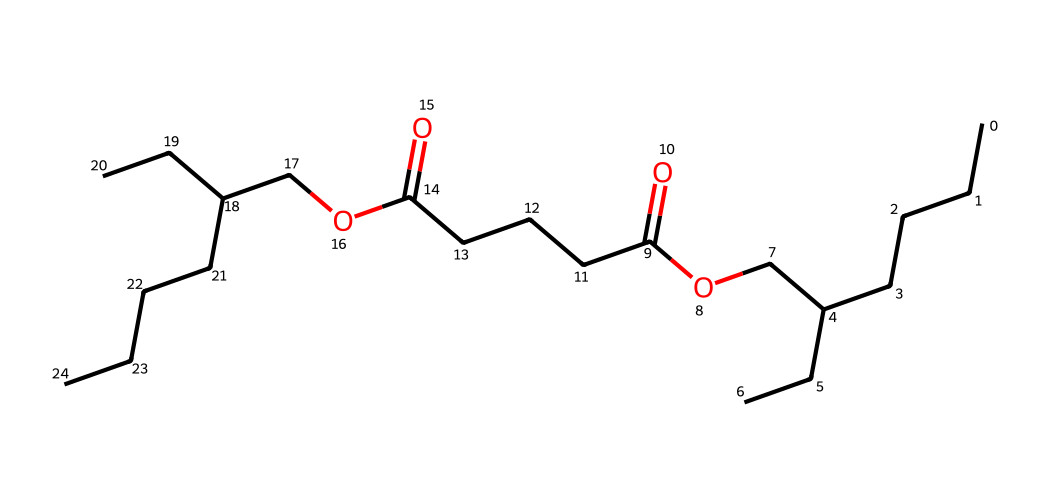how many carbon atoms are in the chemical? By analyzing the SMILES representation, we can count the number of 'C' characters, which represent carbon atoms. In this case, there are 18 carbon atoms present in the structure.
Answer: 18 how many oxygen atoms are present in the chemical? In the SMILES notation, we can identify the 'O' characters representing oxygen atoms. Counting them gives a total of 4 oxygen atoms in this compound.
Answer: 4 what is the functional group present in the chemical? Looking at the structure, we can identify that the SMILES contains 'C(=O)', which indicates the presence of a carboxylic acid functional group in the compound, along with an ester due to the 'O' atoms next to carbon chains.
Answer: carboxylic acid and ester is this compound likely to be polar or nonpolar? Given the presence of long hydrocarbon chains and functional groups, we can reason that while it may have some polar characteristics due to the functional groups, the dominant feature of long nonpolar carbon chains suggests it is primarily nonpolar.
Answer: nonpolar what type of coordination compound could this chemical be categorized as? Analyzing the structure, we see that this compound is large and contains functional groups suggestive of potential interactions with metal ions, likely categorizing it under organic coordination compounds, specifically as a ligand.
Answer: organic coordination compound 